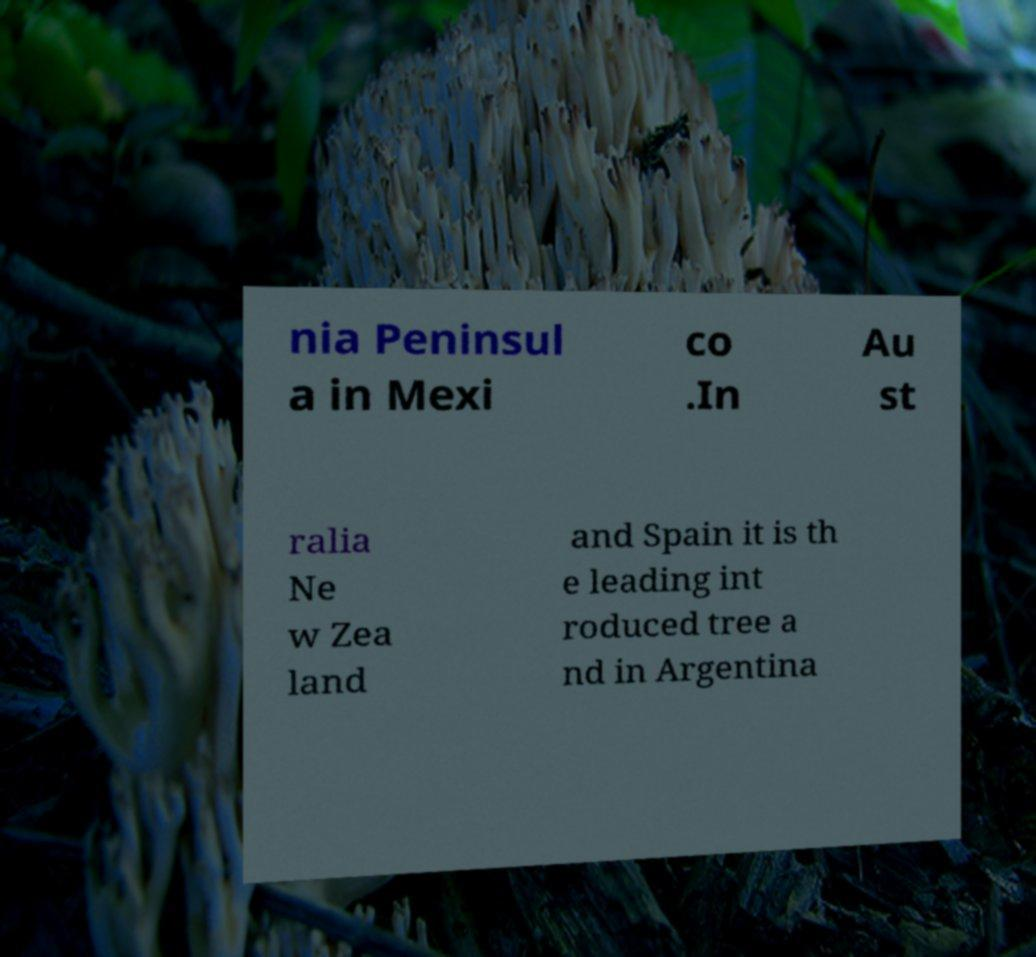For documentation purposes, I need the text within this image transcribed. Could you provide that? nia Peninsul a in Mexi co .In Au st ralia Ne w Zea land and Spain it is th e leading int roduced tree a nd in Argentina 